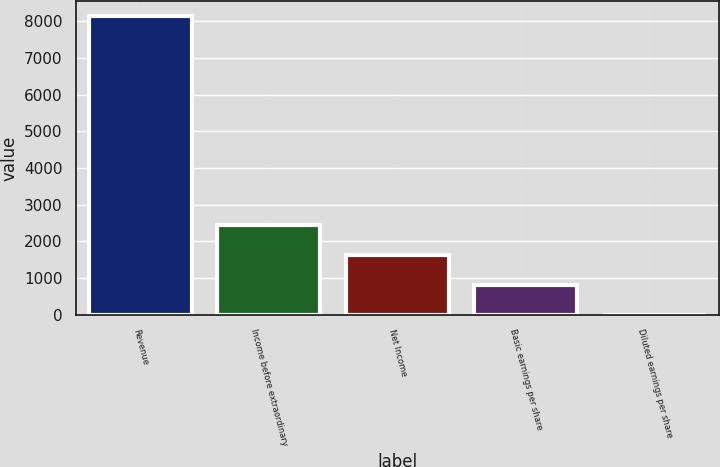Convert chart to OTSL. <chart><loc_0><loc_0><loc_500><loc_500><bar_chart><fcel>Revenue<fcel>Income before extraordinary<fcel>Net Income<fcel>Basic earnings per share<fcel>Diluted earnings per share<nl><fcel>8137<fcel>2442.23<fcel>1628.69<fcel>815.15<fcel>1.61<nl></chart> 